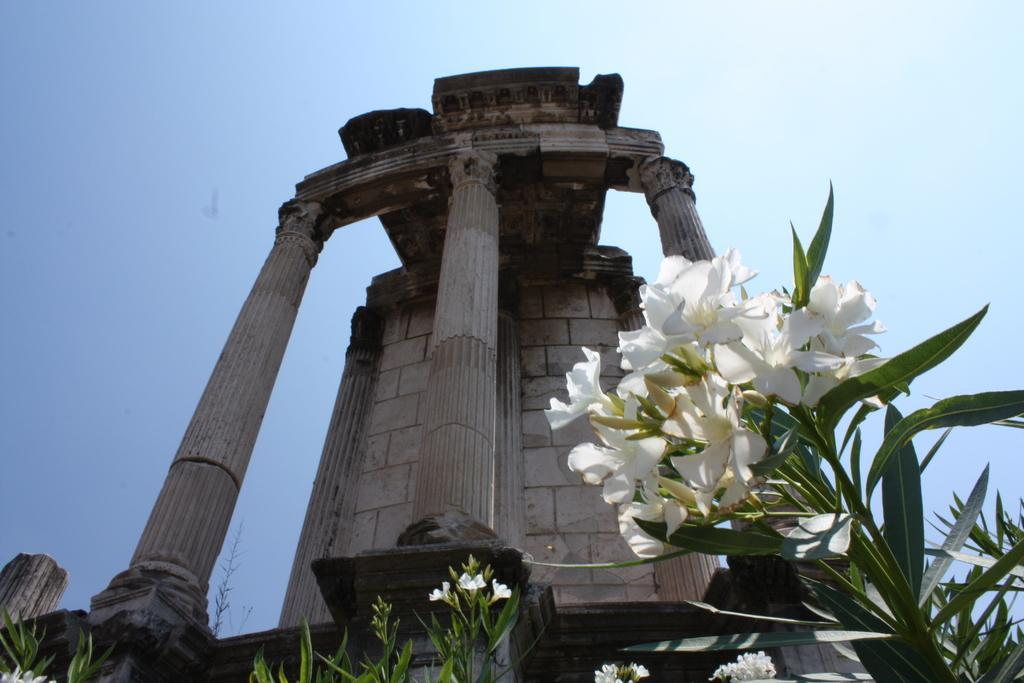What type of plants are at the bottom of the image? There are plants with flowers at the bottom of the image. What is the main structure in the middle of the image? There is a monument in the middle of the image. What color is the sky in the image? The sky is blue at the top of the image. What type of action is the stranger performing with the pickle in the image? There is no stranger or pickle present in the image. 